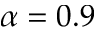Convert formula to latex. <formula><loc_0><loc_0><loc_500><loc_500>\alpha = 0 . 9</formula> 